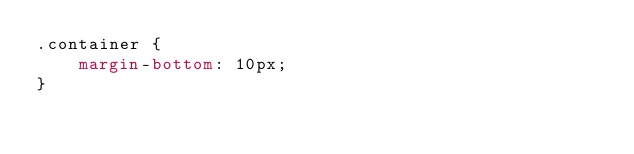<code> <loc_0><loc_0><loc_500><loc_500><_CSS_>.container {
    margin-bottom: 10px;
}</code> 